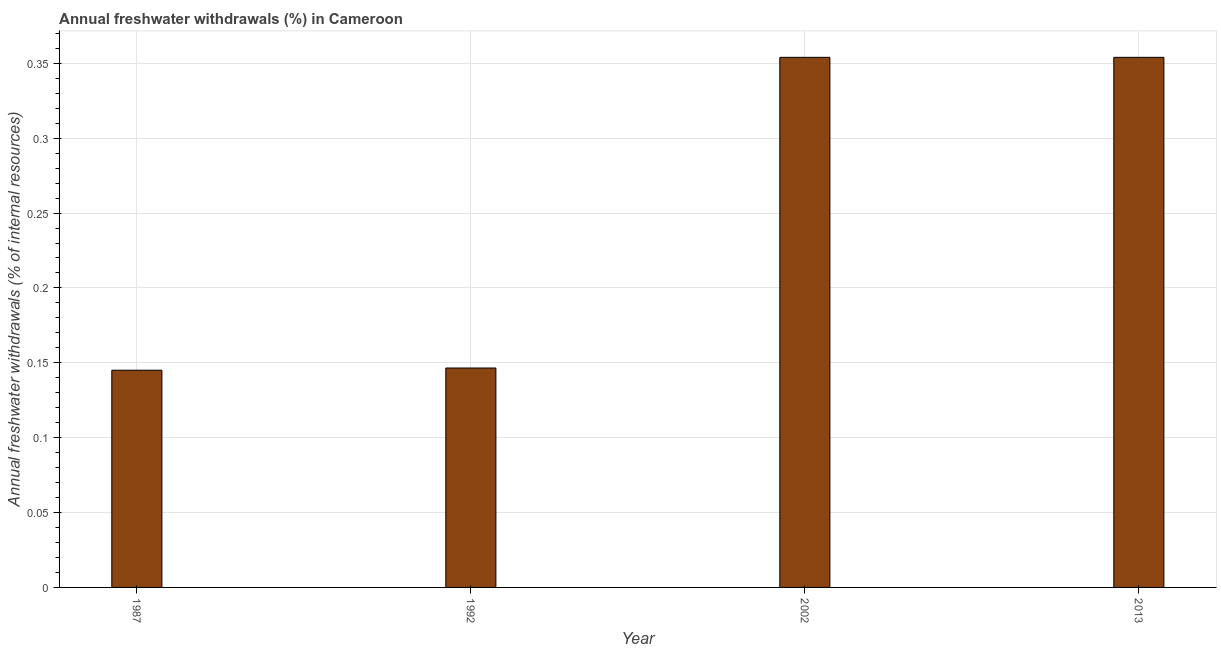Does the graph contain any zero values?
Offer a terse response. No. What is the title of the graph?
Give a very brief answer. Annual freshwater withdrawals (%) in Cameroon. What is the label or title of the X-axis?
Make the answer very short. Year. What is the label or title of the Y-axis?
Give a very brief answer. Annual freshwater withdrawals (% of internal resources). What is the annual freshwater withdrawals in 1992?
Offer a terse response. 0.15. Across all years, what is the maximum annual freshwater withdrawals?
Your answer should be very brief. 0.35. Across all years, what is the minimum annual freshwater withdrawals?
Your answer should be very brief. 0.15. In which year was the annual freshwater withdrawals minimum?
Ensure brevity in your answer.  1987. What is the sum of the annual freshwater withdrawals?
Ensure brevity in your answer.  1. What is the difference between the annual freshwater withdrawals in 1987 and 2002?
Keep it short and to the point. -0.21. What is the median annual freshwater withdrawals?
Make the answer very short. 0.25. Is the annual freshwater withdrawals in 1987 less than that in 2002?
Your response must be concise. Yes. What is the difference between the highest and the lowest annual freshwater withdrawals?
Ensure brevity in your answer.  0.21. Are all the bars in the graph horizontal?
Offer a very short reply. No. What is the difference between two consecutive major ticks on the Y-axis?
Your answer should be very brief. 0.05. Are the values on the major ticks of Y-axis written in scientific E-notation?
Offer a terse response. No. What is the Annual freshwater withdrawals (% of internal resources) of 1987?
Provide a succinct answer. 0.15. What is the Annual freshwater withdrawals (% of internal resources) in 1992?
Keep it short and to the point. 0.15. What is the Annual freshwater withdrawals (% of internal resources) of 2002?
Your answer should be compact. 0.35. What is the Annual freshwater withdrawals (% of internal resources) in 2013?
Give a very brief answer. 0.35. What is the difference between the Annual freshwater withdrawals (% of internal resources) in 1987 and 1992?
Provide a short and direct response. -0. What is the difference between the Annual freshwater withdrawals (% of internal resources) in 1987 and 2002?
Provide a short and direct response. -0.21. What is the difference between the Annual freshwater withdrawals (% of internal resources) in 1987 and 2013?
Your response must be concise. -0.21. What is the difference between the Annual freshwater withdrawals (% of internal resources) in 1992 and 2002?
Keep it short and to the point. -0.21. What is the difference between the Annual freshwater withdrawals (% of internal resources) in 1992 and 2013?
Your answer should be very brief. -0.21. What is the difference between the Annual freshwater withdrawals (% of internal resources) in 2002 and 2013?
Provide a short and direct response. 0. What is the ratio of the Annual freshwater withdrawals (% of internal resources) in 1987 to that in 2002?
Provide a succinct answer. 0.41. What is the ratio of the Annual freshwater withdrawals (% of internal resources) in 1987 to that in 2013?
Offer a terse response. 0.41. What is the ratio of the Annual freshwater withdrawals (% of internal resources) in 1992 to that in 2002?
Keep it short and to the point. 0.41. What is the ratio of the Annual freshwater withdrawals (% of internal resources) in 1992 to that in 2013?
Offer a terse response. 0.41. 